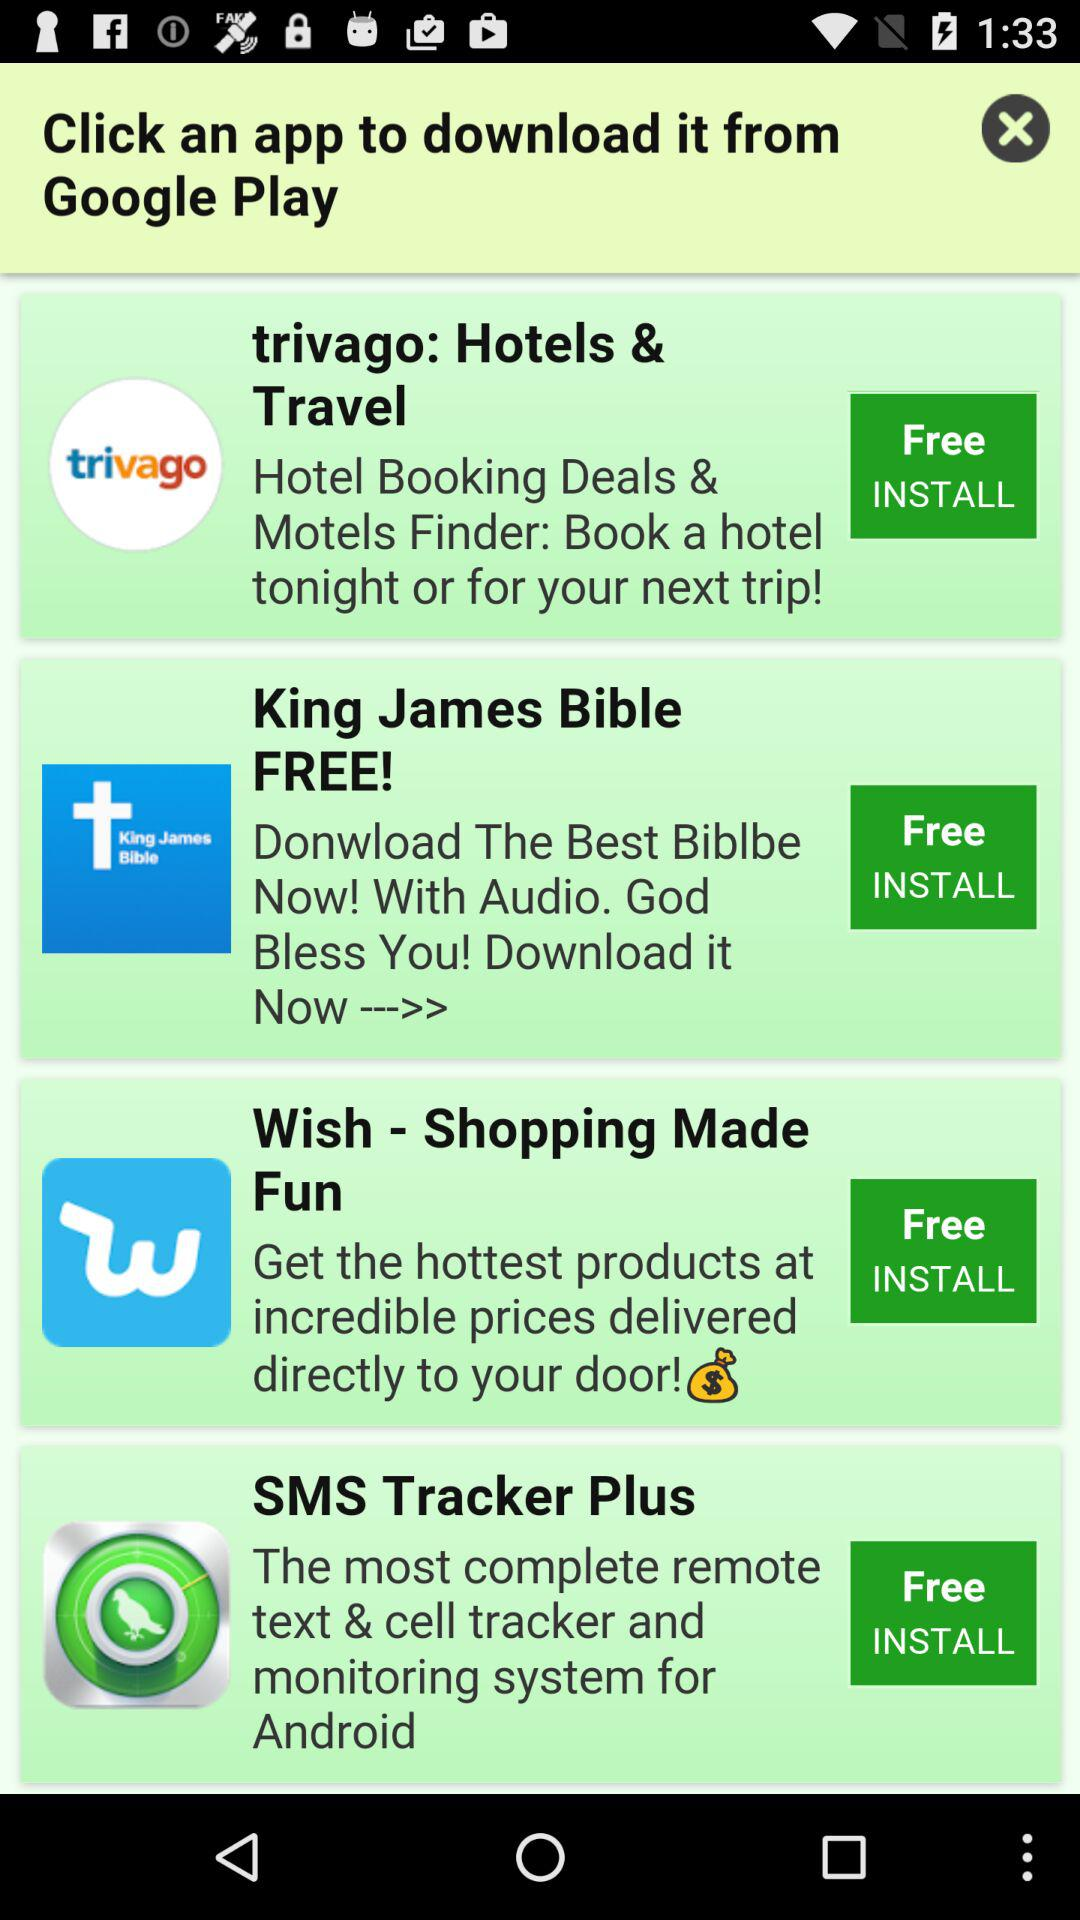From where can we download these apps? You can download these apps from "Google Play". 